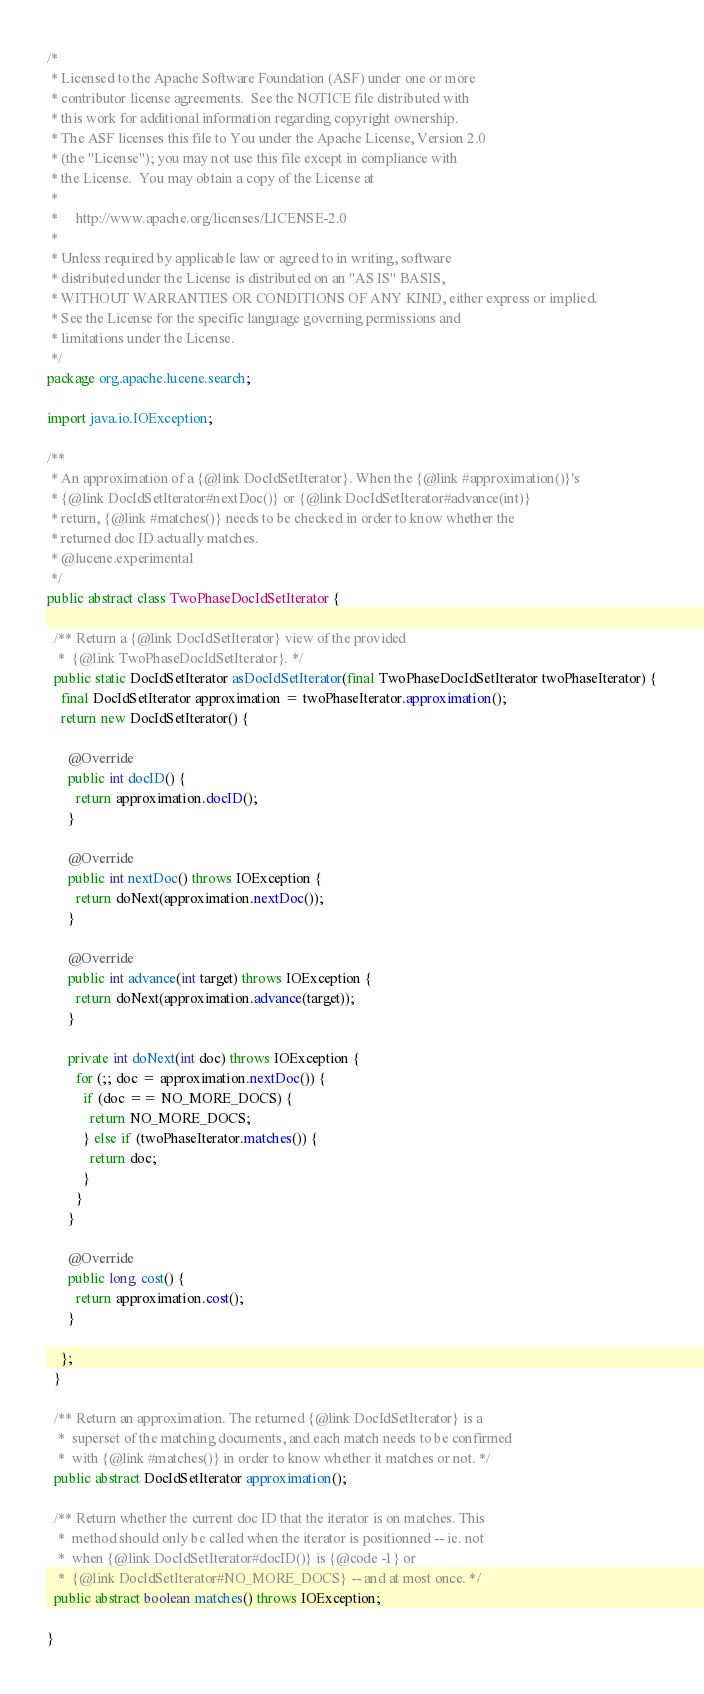<code> <loc_0><loc_0><loc_500><loc_500><_Java_>/*
 * Licensed to the Apache Software Foundation (ASF) under one or more
 * contributor license agreements.  See the NOTICE file distributed with
 * this work for additional information regarding copyright ownership.
 * The ASF licenses this file to You under the Apache License, Version 2.0
 * (the "License"); you may not use this file except in compliance with
 * the License.  You may obtain a copy of the License at
 *
 *     http://www.apache.org/licenses/LICENSE-2.0
 *
 * Unless required by applicable law or agreed to in writing, software
 * distributed under the License is distributed on an "AS IS" BASIS,
 * WITHOUT WARRANTIES OR CONDITIONS OF ANY KIND, either express or implied.
 * See the License for the specific language governing permissions and
 * limitations under the License.
 */
package org.apache.lucene.search;

import java.io.IOException;

/**
 * An approximation of a {@link DocIdSetIterator}. When the {@link #approximation()}'s
 * {@link DocIdSetIterator#nextDoc()} or {@link DocIdSetIterator#advance(int)}
 * return, {@link #matches()} needs to be checked in order to know whether the
 * returned doc ID actually matches.
 * @lucene.experimental
 */
public abstract class TwoPhaseDocIdSetIterator {

  /** Return a {@link DocIdSetIterator} view of the provided
   *  {@link TwoPhaseDocIdSetIterator}. */
  public static DocIdSetIterator asDocIdSetIterator(final TwoPhaseDocIdSetIterator twoPhaseIterator) {
    final DocIdSetIterator approximation = twoPhaseIterator.approximation();
    return new DocIdSetIterator() {

      @Override
      public int docID() {
        return approximation.docID();
      }

      @Override
      public int nextDoc() throws IOException {
        return doNext(approximation.nextDoc());
      }

      @Override
      public int advance(int target) throws IOException {
        return doNext(approximation.advance(target));
      }

      private int doNext(int doc) throws IOException {
        for (;; doc = approximation.nextDoc()) {
          if (doc == NO_MORE_DOCS) {
            return NO_MORE_DOCS;
          } else if (twoPhaseIterator.matches()) {
            return doc;
          }
        }
      }

      @Override
      public long cost() {
        return approximation.cost();
      }

    };
  }

  /** Return an approximation. The returned {@link DocIdSetIterator} is a
   *  superset of the matching documents, and each match needs to be confirmed
   *  with {@link #matches()} in order to know whether it matches or not. */
  public abstract DocIdSetIterator approximation();

  /** Return whether the current doc ID that the iterator is on matches. This
   *  method should only be called when the iterator is positionned -- ie. not
   *  when {@link DocIdSetIterator#docID()} is {@code -1} or
   *  {@link DocIdSetIterator#NO_MORE_DOCS} -- and at most once. */
  public abstract boolean matches() throws IOException;

}
</code> 